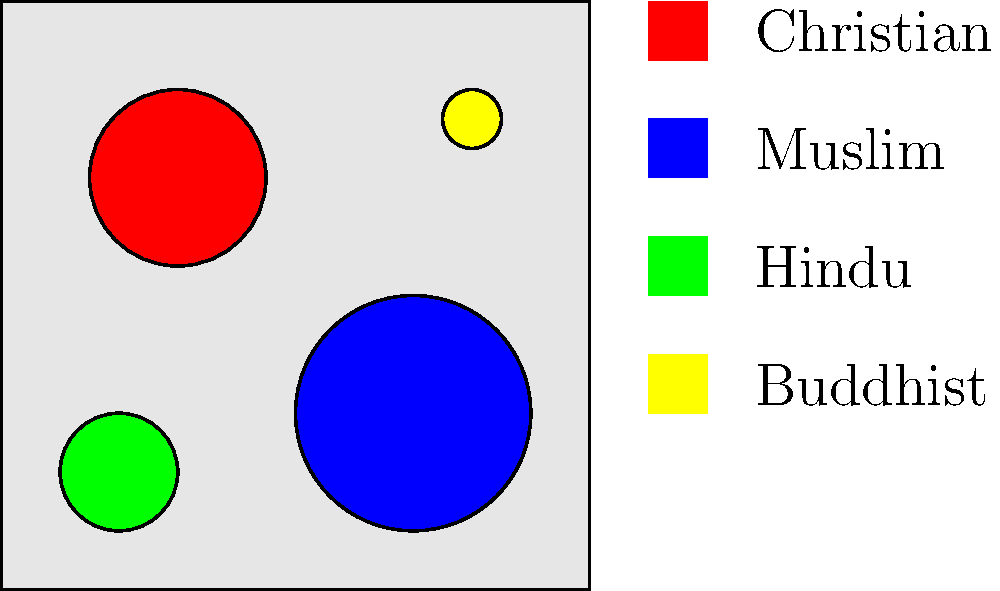Based on the color-coded map of faith communities in your local area, which faith group appears to have the largest geographical presence, and what insights can you draw about the distribution of different faiths that might be relevant for promoting interfaith dialogue? To answer this question, let's analyze the map step-by-step:

1. Identify the faith communities:
   - Red: Christian
   - Blue: Muslim
   - Green: Hindu
   - Yellow: Buddhist

2. Compare the size and distribution of colored circles:
   - The red (Christian) circle is large and located in the upper-left quadrant.
   - The blue (Muslim) circle is the largest and positioned in the lower-right quadrant.
   - The green (Hindu) circle is medium-sized and in the lower-left corner.
   - The yellow (Buddhist) circle is the smallest and in the upper-right corner.

3. Analyze geographical presence:
   - The Muslim community (blue) appears to have the largest geographical presence due to the size of its circle.

4. Draw insights for interfaith dialogue:
   a) Proximity: Christian and Hindu communities are closer to each other, potentially indicating more interaction opportunities.
   b) Size variation: The significant difference in community sizes suggests a need for balanced representation in dialogues.
   c) Distribution: Communities are spread across different quadrants, implying a diverse religious landscape that could benefit from increased understanding and communication.
   d) Minority presence: The small Buddhist community might require special attention to ensure their voices are heard in interfaith initiatives.

5. Relevance for promoting interfaith dialogue:
   - Target areas where communities overlap or are in close proximity for initial dialogue efforts.
   - Design inclusive programs that cater to both larger and smaller faith groups.
   - Address potential isolation of smaller communities (e.g., Buddhist) by creating specific outreach strategies.
   - Use the geographical distribution to plan location-specific events that maximize participation from different faith groups.
Answer: Muslim community has the largest presence; insights include varied community sizes, diverse distribution, and opportunities for targeted interfaith initiatives based on proximity and representation. 